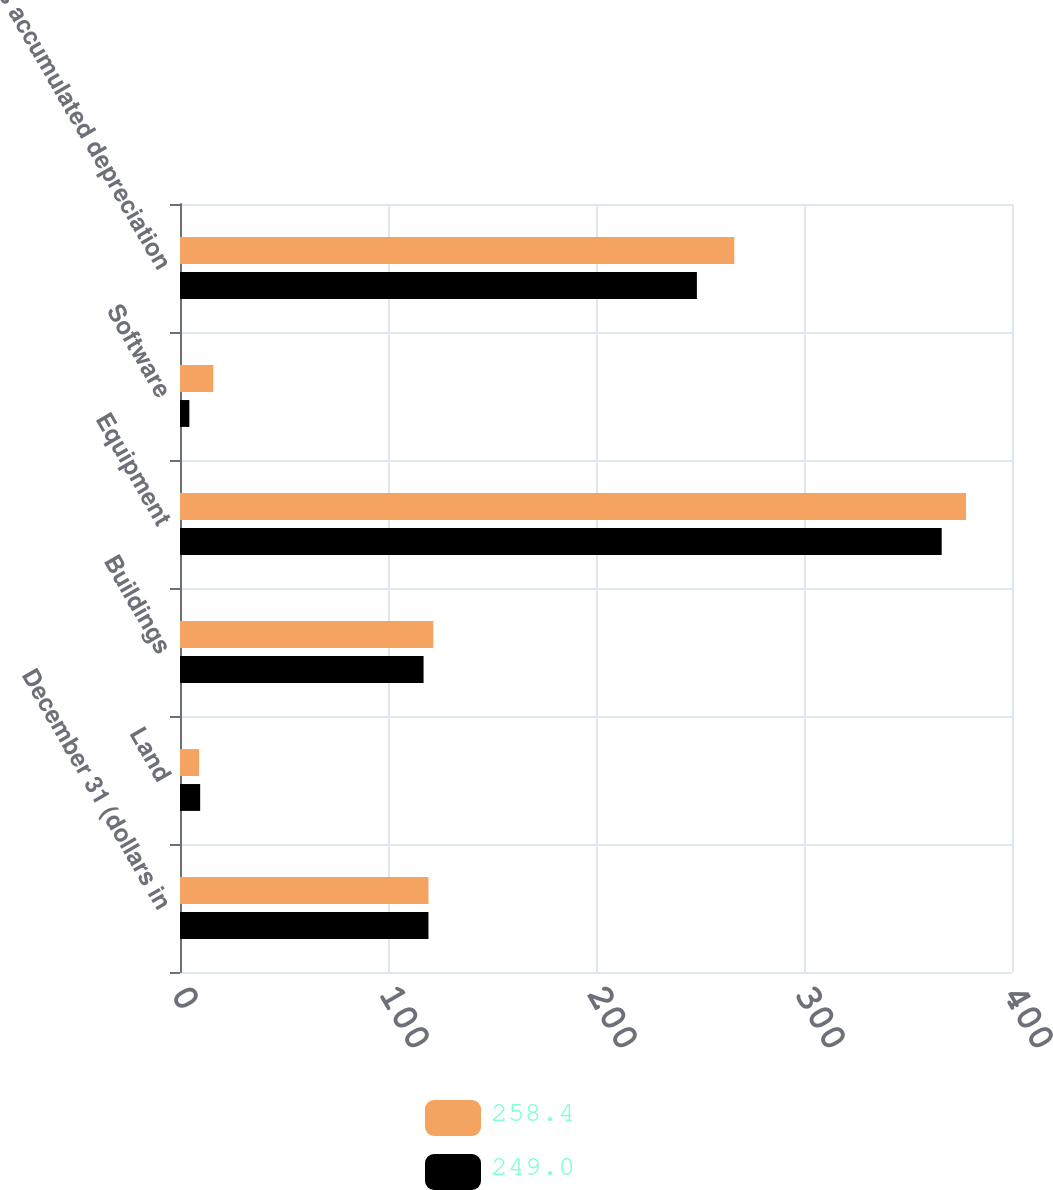Convert chart. <chart><loc_0><loc_0><loc_500><loc_500><stacked_bar_chart><ecel><fcel>December 31 (dollars in<fcel>Land<fcel>Buildings<fcel>Equipment<fcel>Software<fcel>Less accumulated depreciation<nl><fcel>258.4<fcel>119.45<fcel>9.2<fcel>121.8<fcel>377.9<fcel>16<fcel>266.5<nl><fcel>249<fcel>119.45<fcel>9.7<fcel>117.1<fcel>366.2<fcel>4.5<fcel>248.5<nl></chart> 